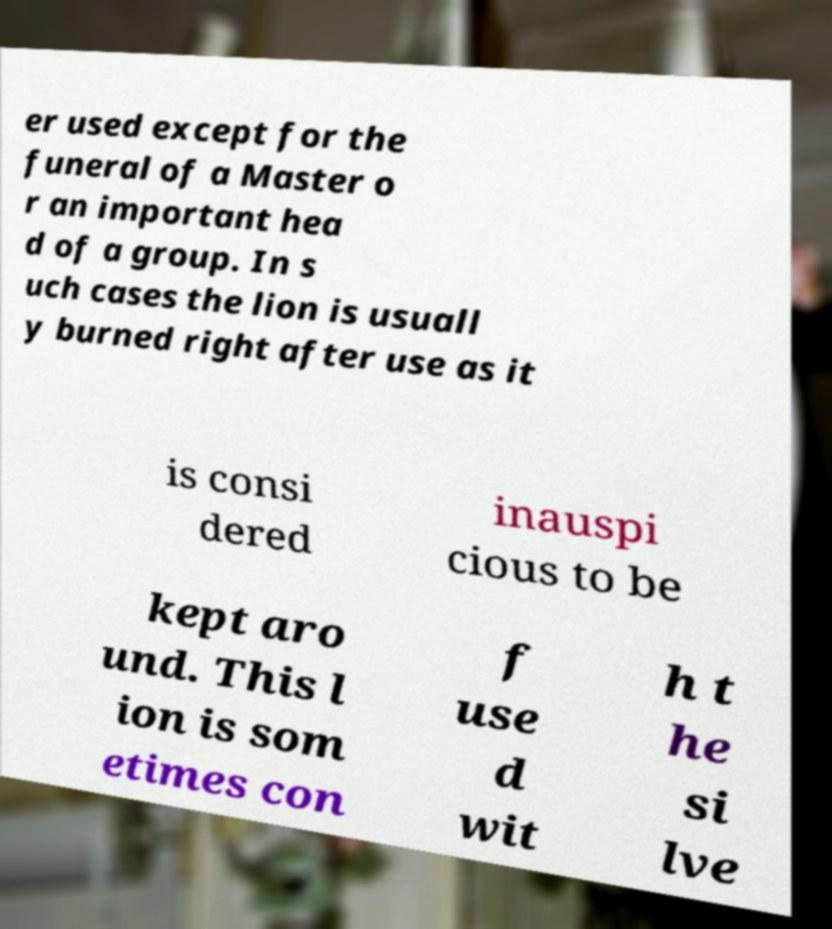For documentation purposes, I need the text within this image transcribed. Could you provide that? er used except for the funeral of a Master o r an important hea d of a group. In s uch cases the lion is usuall y burned right after use as it is consi dered inauspi cious to be kept aro und. This l ion is som etimes con f use d wit h t he si lve 